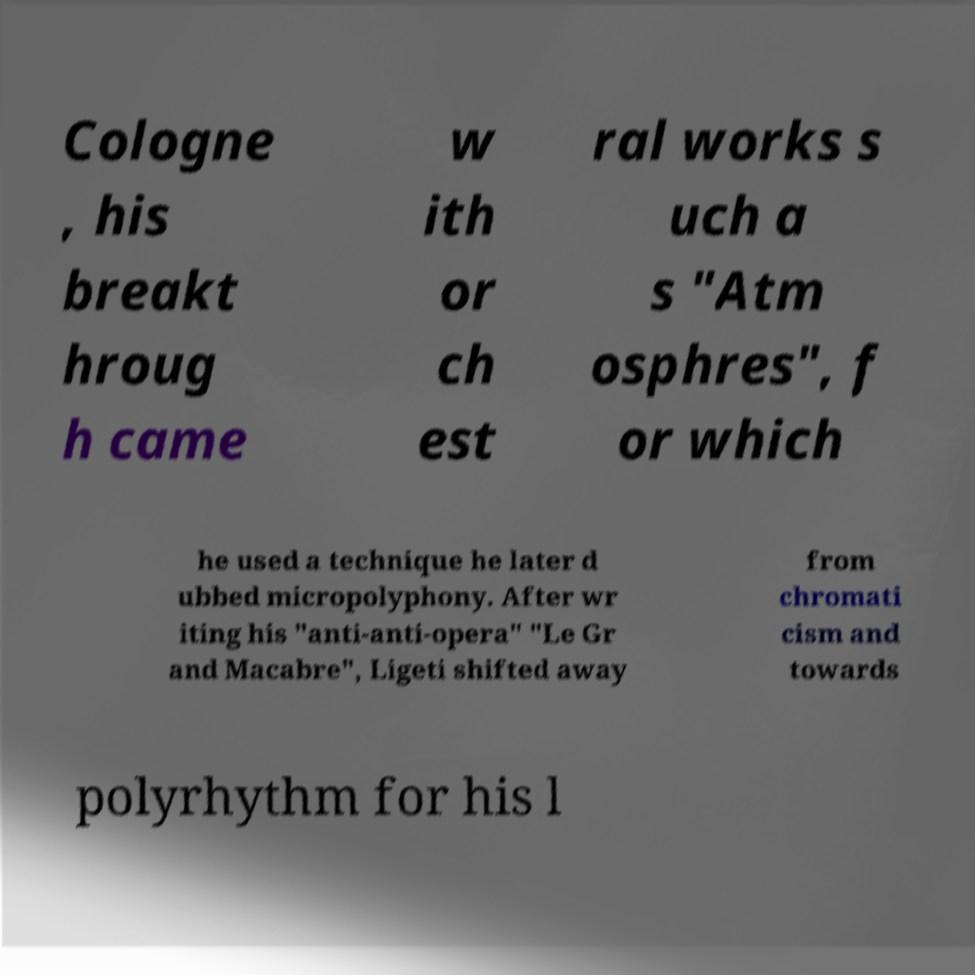Could you extract and type out the text from this image? Cologne , his breakt hroug h came w ith or ch est ral works s uch a s "Atm osphres", f or which he used a technique he later d ubbed micropolyphony. After wr iting his "anti-anti-opera" "Le Gr and Macabre", Ligeti shifted away from chromati cism and towards polyrhythm for his l 